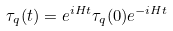Convert formula to latex. <formula><loc_0><loc_0><loc_500><loc_500>\tau _ { q } ( t ) = e ^ { i H t } \tau _ { q } ( 0 ) e ^ { - i H t }</formula> 